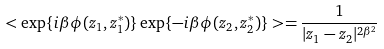Convert formula to latex. <formula><loc_0><loc_0><loc_500><loc_500>< \exp \{ i \beta \phi ( z _ { 1 } , z _ { 1 } ^ { * } ) \} \exp \{ - i \beta \phi ( z _ { 2 } , z _ { 2 } ^ { * } ) \} > = \frac { 1 } { | z _ { 1 } - z _ { 2 } | ^ { 2 \beta ^ { 2 } } }</formula> 